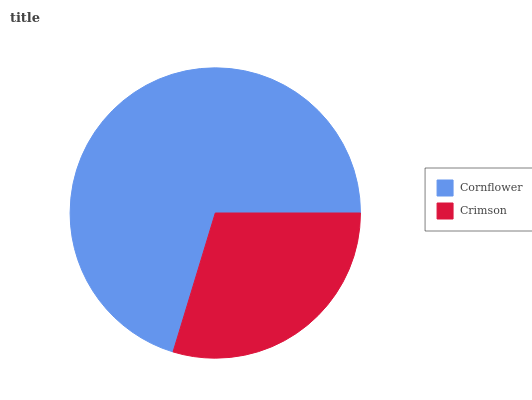Is Crimson the minimum?
Answer yes or no. Yes. Is Cornflower the maximum?
Answer yes or no. Yes. Is Crimson the maximum?
Answer yes or no. No. Is Cornflower greater than Crimson?
Answer yes or no. Yes. Is Crimson less than Cornflower?
Answer yes or no. Yes. Is Crimson greater than Cornflower?
Answer yes or no. No. Is Cornflower less than Crimson?
Answer yes or no. No. Is Cornflower the high median?
Answer yes or no. Yes. Is Crimson the low median?
Answer yes or no. Yes. Is Crimson the high median?
Answer yes or no. No. Is Cornflower the low median?
Answer yes or no. No. 